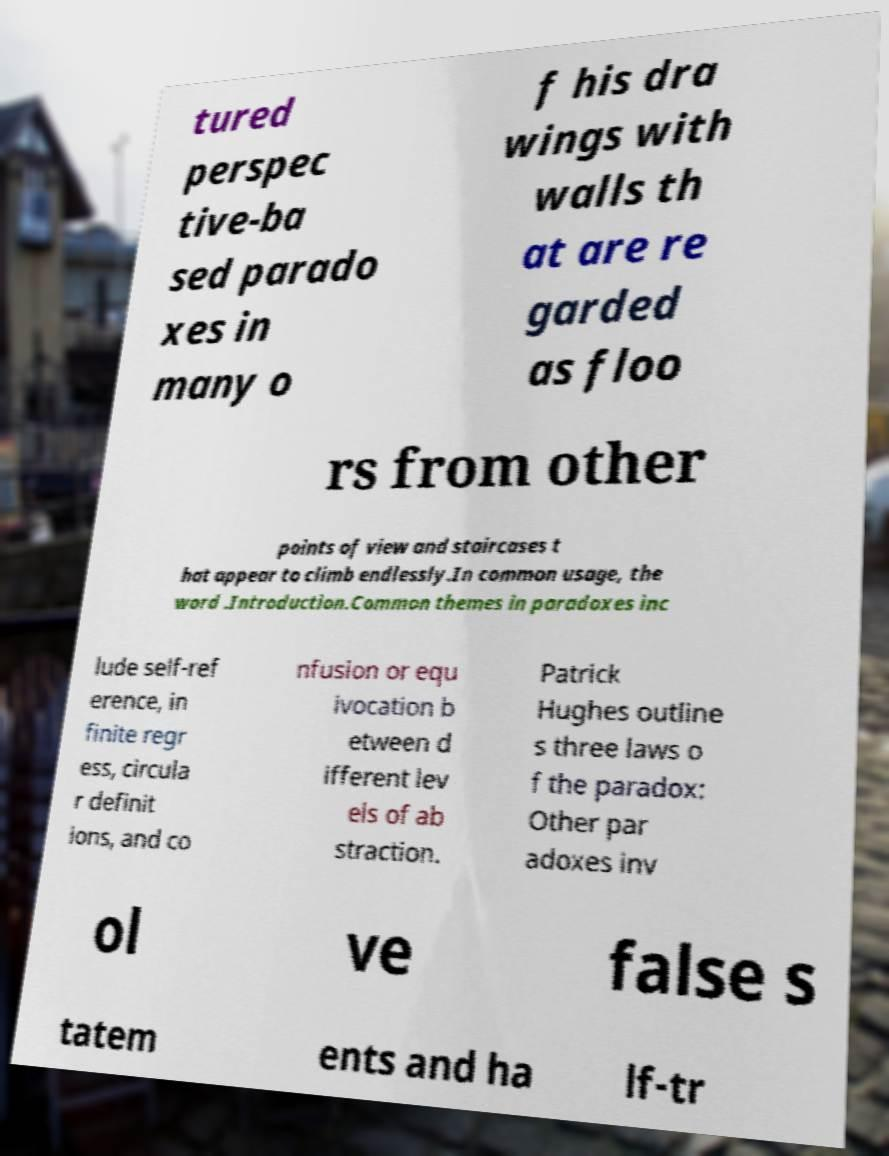Please identify and transcribe the text found in this image. tured perspec tive-ba sed parado xes in many o f his dra wings with walls th at are re garded as floo rs from other points of view and staircases t hat appear to climb endlessly.In common usage, the word .Introduction.Common themes in paradoxes inc lude self-ref erence, in finite regr ess, circula r definit ions, and co nfusion or equ ivocation b etween d ifferent lev els of ab straction. Patrick Hughes outline s three laws o f the paradox: Other par adoxes inv ol ve false s tatem ents and ha lf-tr 